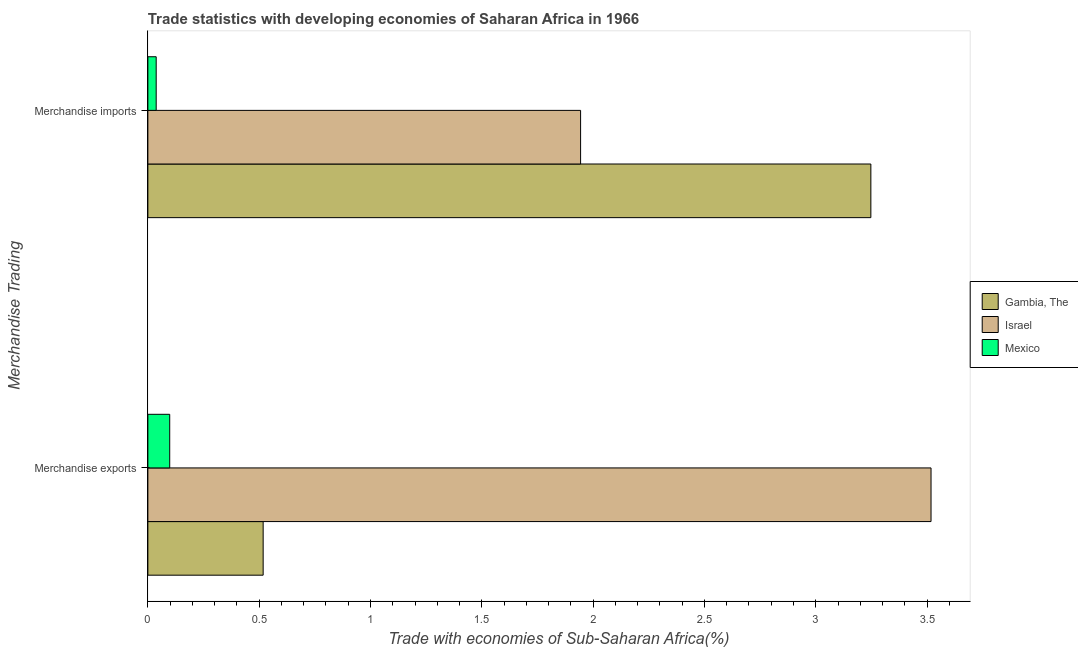How many groups of bars are there?
Provide a short and direct response. 2. Are the number of bars on each tick of the Y-axis equal?
Your answer should be very brief. Yes. What is the label of the 1st group of bars from the top?
Your answer should be very brief. Merchandise imports. What is the merchandise imports in Israel?
Offer a very short reply. 1.94. Across all countries, what is the maximum merchandise imports?
Offer a terse response. 3.25. Across all countries, what is the minimum merchandise imports?
Keep it short and to the point. 0.04. In which country was the merchandise exports maximum?
Your answer should be very brief. Israel. What is the total merchandise exports in the graph?
Your answer should be compact. 4.13. What is the difference between the merchandise imports in Gambia, The and that in Mexico?
Make the answer very short. 3.21. What is the difference between the merchandise exports in Israel and the merchandise imports in Gambia, The?
Your answer should be very brief. 0.27. What is the average merchandise exports per country?
Provide a short and direct response. 1.38. What is the difference between the merchandise exports and merchandise imports in Israel?
Provide a succinct answer. 1.57. In how many countries, is the merchandise exports greater than 2.7 %?
Offer a terse response. 1. What is the ratio of the merchandise exports in Israel to that in Gambia, The?
Make the answer very short. 6.79. What does the 3rd bar from the top in Merchandise exports represents?
Make the answer very short. Gambia, The. How many bars are there?
Ensure brevity in your answer.  6. How many countries are there in the graph?
Your answer should be compact. 3. Where does the legend appear in the graph?
Offer a terse response. Center right. What is the title of the graph?
Your answer should be very brief. Trade statistics with developing economies of Saharan Africa in 1966. Does "Central Europe" appear as one of the legend labels in the graph?
Offer a terse response. No. What is the label or title of the X-axis?
Offer a terse response. Trade with economies of Sub-Saharan Africa(%). What is the label or title of the Y-axis?
Ensure brevity in your answer.  Merchandise Trading. What is the Trade with economies of Sub-Saharan Africa(%) of Gambia, The in Merchandise exports?
Give a very brief answer. 0.52. What is the Trade with economies of Sub-Saharan Africa(%) in Israel in Merchandise exports?
Offer a terse response. 3.52. What is the Trade with economies of Sub-Saharan Africa(%) of Mexico in Merchandise exports?
Offer a terse response. 0.1. What is the Trade with economies of Sub-Saharan Africa(%) in Gambia, The in Merchandise imports?
Give a very brief answer. 3.25. What is the Trade with economies of Sub-Saharan Africa(%) of Israel in Merchandise imports?
Make the answer very short. 1.94. What is the Trade with economies of Sub-Saharan Africa(%) of Mexico in Merchandise imports?
Offer a terse response. 0.04. Across all Merchandise Trading, what is the maximum Trade with economies of Sub-Saharan Africa(%) of Gambia, The?
Ensure brevity in your answer.  3.25. Across all Merchandise Trading, what is the maximum Trade with economies of Sub-Saharan Africa(%) in Israel?
Offer a very short reply. 3.52. Across all Merchandise Trading, what is the maximum Trade with economies of Sub-Saharan Africa(%) of Mexico?
Ensure brevity in your answer.  0.1. Across all Merchandise Trading, what is the minimum Trade with economies of Sub-Saharan Africa(%) in Gambia, The?
Ensure brevity in your answer.  0.52. Across all Merchandise Trading, what is the minimum Trade with economies of Sub-Saharan Africa(%) of Israel?
Your response must be concise. 1.94. Across all Merchandise Trading, what is the minimum Trade with economies of Sub-Saharan Africa(%) in Mexico?
Offer a terse response. 0.04. What is the total Trade with economies of Sub-Saharan Africa(%) of Gambia, The in the graph?
Provide a short and direct response. 3.77. What is the total Trade with economies of Sub-Saharan Africa(%) of Israel in the graph?
Provide a succinct answer. 5.46. What is the total Trade with economies of Sub-Saharan Africa(%) of Mexico in the graph?
Ensure brevity in your answer.  0.14. What is the difference between the Trade with economies of Sub-Saharan Africa(%) in Gambia, The in Merchandise exports and that in Merchandise imports?
Provide a succinct answer. -2.73. What is the difference between the Trade with economies of Sub-Saharan Africa(%) of Israel in Merchandise exports and that in Merchandise imports?
Ensure brevity in your answer.  1.57. What is the difference between the Trade with economies of Sub-Saharan Africa(%) in Mexico in Merchandise exports and that in Merchandise imports?
Keep it short and to the point. 0.06. What is the difference between the Trade with economies of Sub-Saharan Africa(%) of Gambia, The in Merchandise exports and the Trade with economies of Sub-Saharan Africa(%) of Israel in Merchandise imports?
Your answer should be compact. -1.43. What is the difference between the Trade with economies of Sub-Saharan Africa(%) of Gambia, The in Merchandise exports and the Trade with economies of Sub-Saharan Africa(%) of Mexico in Merchandise imports?
Make the answer very short. 0.48. What is the difference between the Trade with economies of Sub-Saharan Africa(%) in Israel in Merchandise exports and the Trade with economies of Sub-Saharan Africa(%) in Mexico in Merchandise imports?
Keep it short and to the point. 3.48. What is the average Trade with economies of Sub-Saharan Africa(%) in Gambia, The per Merchandise Trading?
Make the answer very short. 1.88. What is the average Trade with economies of Sub-Saharan Africa(%) in Israel per Merchandise Trading?
Your answer should be compact. 2.73. What is the average Trade with economies of Sub-Saharan Africa(%) in Mexico per Merchandise Trading?
Your answer should be very brief. 0.07. What is the difference between the Trade with economies of Sub-Saharan Africa(%) of Gambia, The and Trade with economies of Sub-Saharan Africa(%) of Israel in Merchandise exports?
Your answer should be very brief. -3. What is the difference between the Trade with economies of Sub-Saharan Africa(%) in Gambia, The and Trade with economies of Sub-Saharan Africa(%) in Mexico in Merchandise exports?
Your response must be concise. 0.42. What is the difference between the Trade with economies of Sub-Saharan Africa(%) of Israel and Trade with economies of Sub-Saharan Africa(%) of Mexico in Merchandise exports?
Your answer should be very brief. 3.42. What is the difference between the Trade with economies of Sub-Saharan Africa(%) in Gambia, The and Trade with economies of Sub-Saharan Africa(%) in Israel in Merchandise imports?
Your answer should be compact. 1.3. What is the difference between the Trade with economies of Sub-Saharan Africa(%) in Gambia, The and Trade with economies of Sub-Saharan Africa(%) in Mexico in Merchandise imports?
Your response must be concise. 3.21. What is the difference between the Trade with economies of Sub-Saharan Africa(%) in Israel and Trade with economies of Sub-Saharan Africa(%) in Mexico in Merchandise imports?
Your response must be concise. 1.91. What is the ratio of the Trade with economies of Sub-Saharan Africa(%) of Gambia, The in Merchandise exports to that in Merchandise imports?
Make the answer very short. 0.16. What is the ratio of the Trade with economies of Sub-Saharan Africa(%) in Israel in Merchandise exports to that in Merchandise imports?
Offer a very short reply. 1.81. What is the ratio of the Trade with economies of Sub-Saharan Africa(%) of Mexico in Merchandise exports to that in Merchandise imports?
Your answer should be very brief. 2.62. What is the difference between the highest and the second highest Trade with economies of Sub-Saharan Africa(%) in Gambia, The?
Your response must be concise. 2.73. What is the difference between the highest and the second highest Trade with economies of Sub-Saharan Africa(%) in Israel?
Ensure brevity in your answer.  1.57. What is the difference between the highest and the second highest Trade with economies of Sub-Saharan Africa(%) of Mexico?
Your answer should be compact. 0.06. What is the difference between the highest and the lowest Trade with economies of Sub-Saharan Africa(%) in Gambia, The?
Keep it short and to the point. 2.73. What is the difference between the highest and the lowest Trade with economies of Sub-Saharan Africa(%) of Israel?
Offer a terse response. 1.57. What is the difference between the highest and the lowest Trade with economies of Sub-Saharan Africa(%) of Mexico?
Make the answer very short. 0.06. 